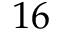<formula> <loc_0><loc_0><loc_500><loc_500>1 6</formula> 